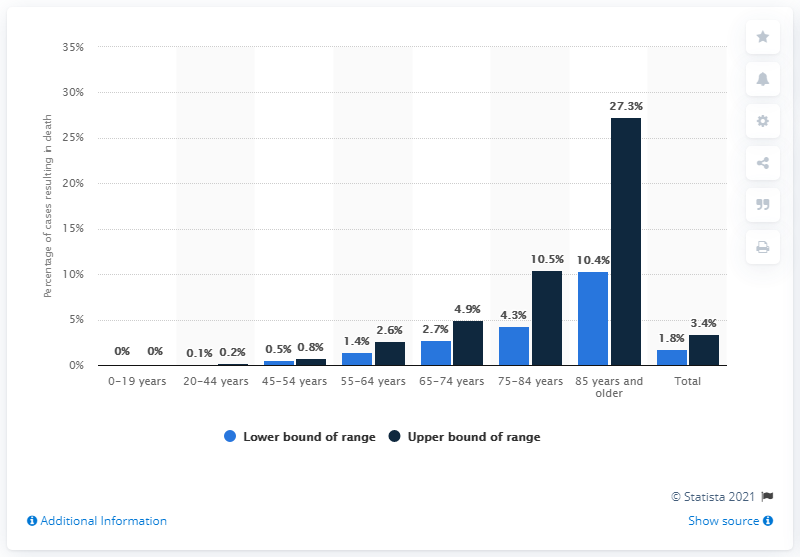Give some essential details in this illustration. According to data from the United States, the highest case-fatality rates among COVID-19 patients were observed in individuals aged 85 years and older during the period of February 12 to March 16, 2020. 